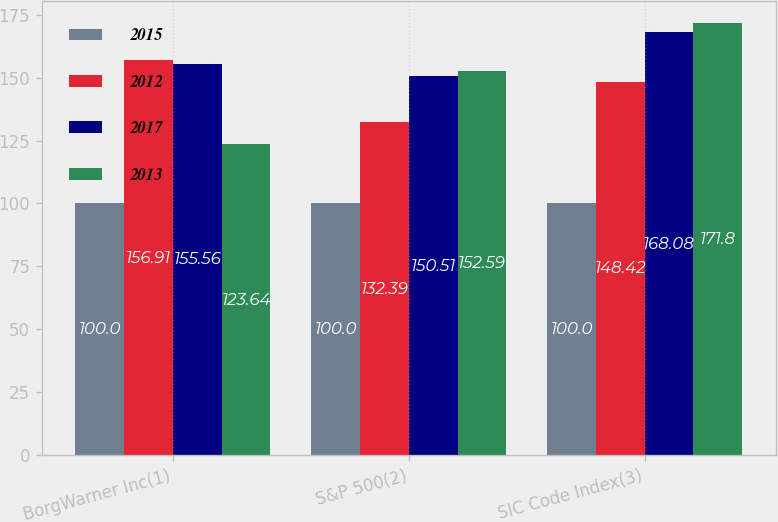Convert chart to OTSL. <chart><loc_0><loc_0><loc_500><loc_500><stacked_bar_chart><ecel><fcel>BorgWarner Inc(1)<fcel>S&P 500(2)<fcel>SIC Code Index(3)<nl><fcel>2015<fcel>100<fcel>100<fcel>100<nl><fcel>2012<fcel>156.91<fcel>132.39<fcel>148.42<nl><fcel>2017<fcel>155.56<fcel>150.51<fcel>168.08<nl><fcel>2013<fcel>123.64<fcel>152.59<fcel>171.8<nl></chart> 